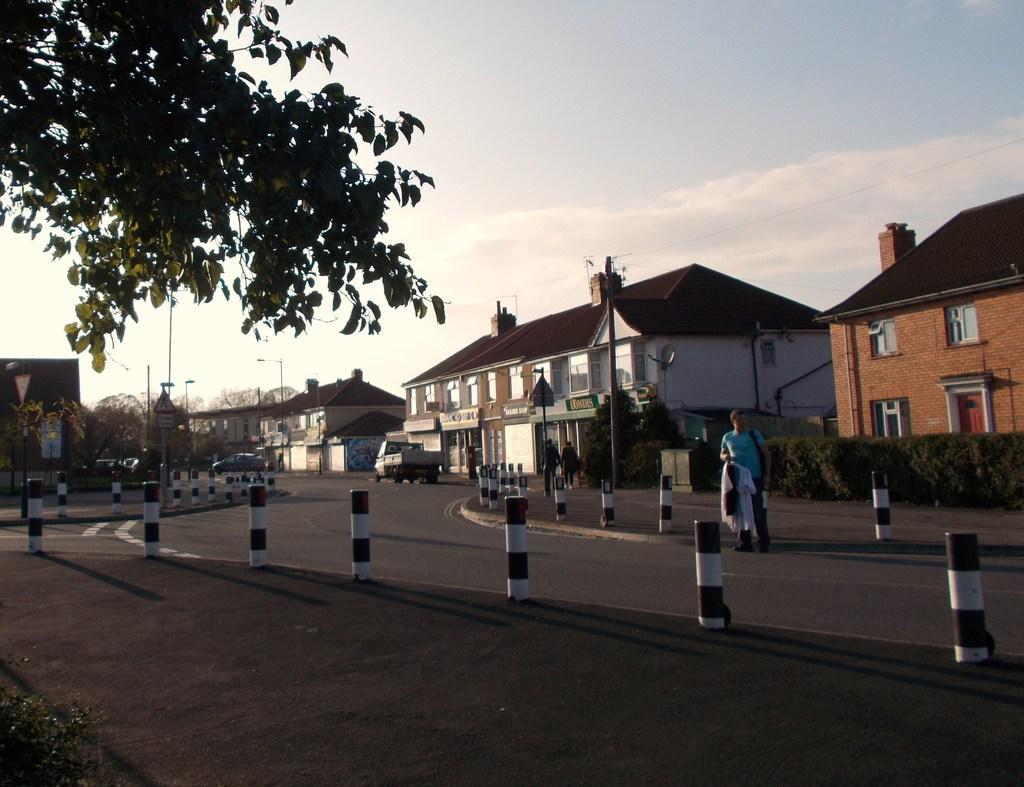Describe this image in one or two sentences. In this image there are trees, poles, boards, buildings, vehicles, road, people, cloudy sky, rods and objects. Among them a person is holding an object. Vehicles are on the road. 